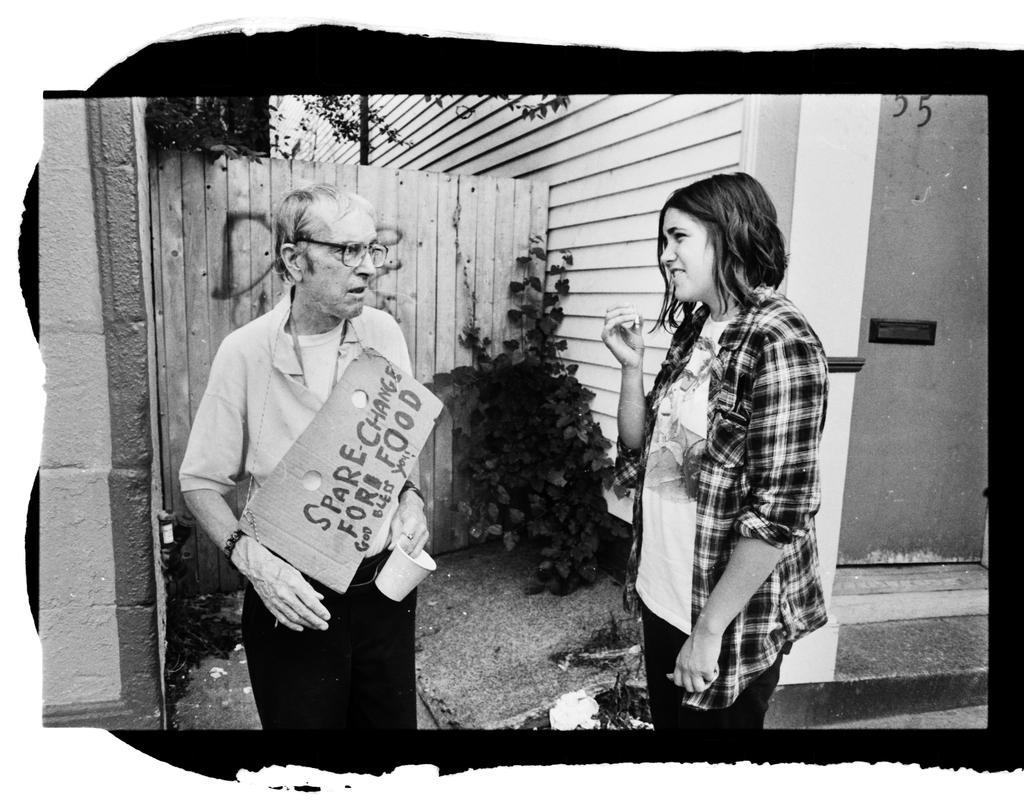In one or two sentences, can you explain what this image depicts? As we can see in the image there is a wall, door, plant and two people standing over here. 